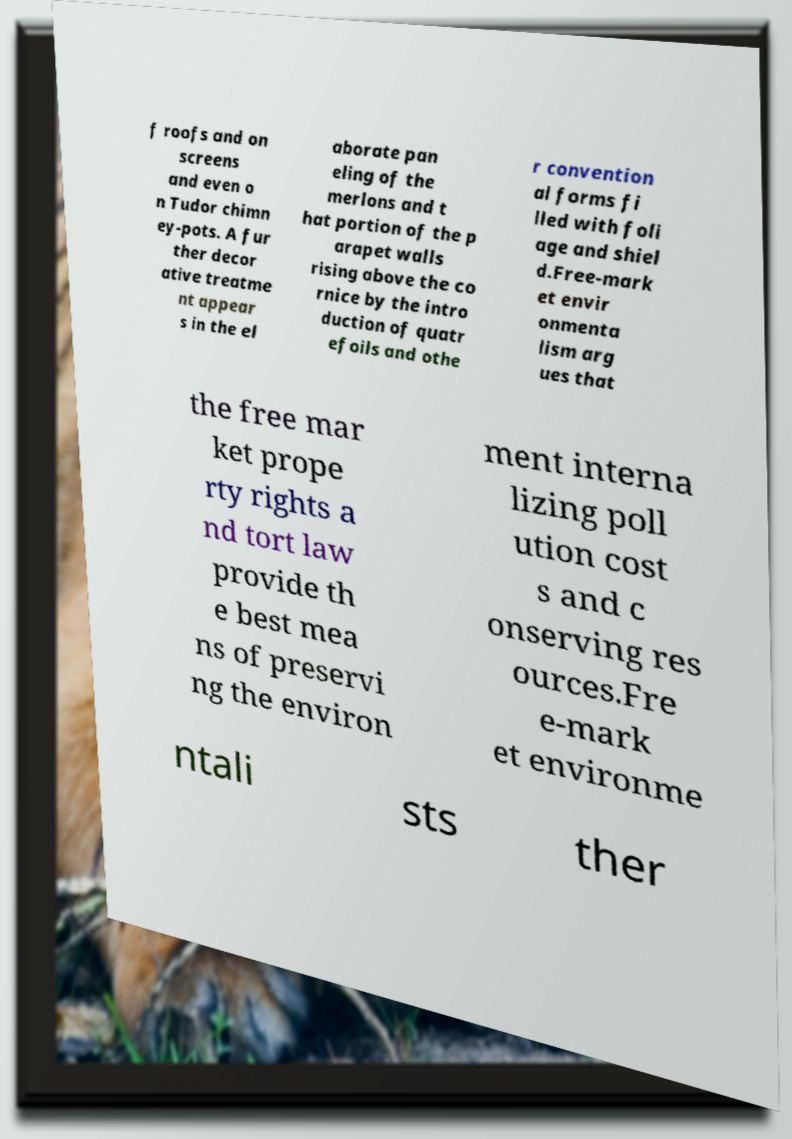Can you read and provide the text displayed in the image?This photo seems to have some interesting text. Can you extract and type it out for me? f roofs and on screens and even o n Tudor chimn ey-pots. A fur ther decor ative treatme nt appear s in the el aborate pan eling of the merlons and t hat portion of the p arapet walls rising above the co rnice by the intro duction of quatr efoils and othe r convention al forms fi lled with foli age and shiel d.Free-mark et envir onmenta lism arg ues that the free mar ket prope rty rights a nd tort law provide th e best mea ns of preservi ng the environ ment interna lizing poll ution cost s and c onserving res ources.Fre e-mark et environme ntali sts ther 